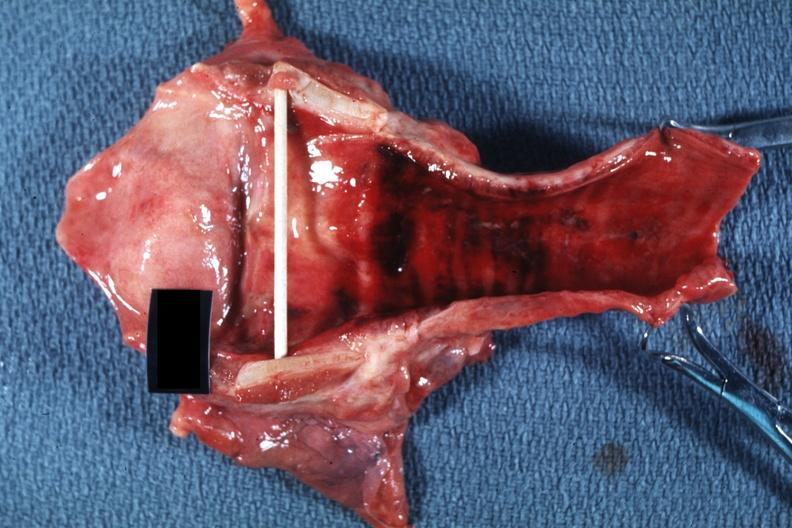where is this?
Answer the question using a single word or phrase. Oral 